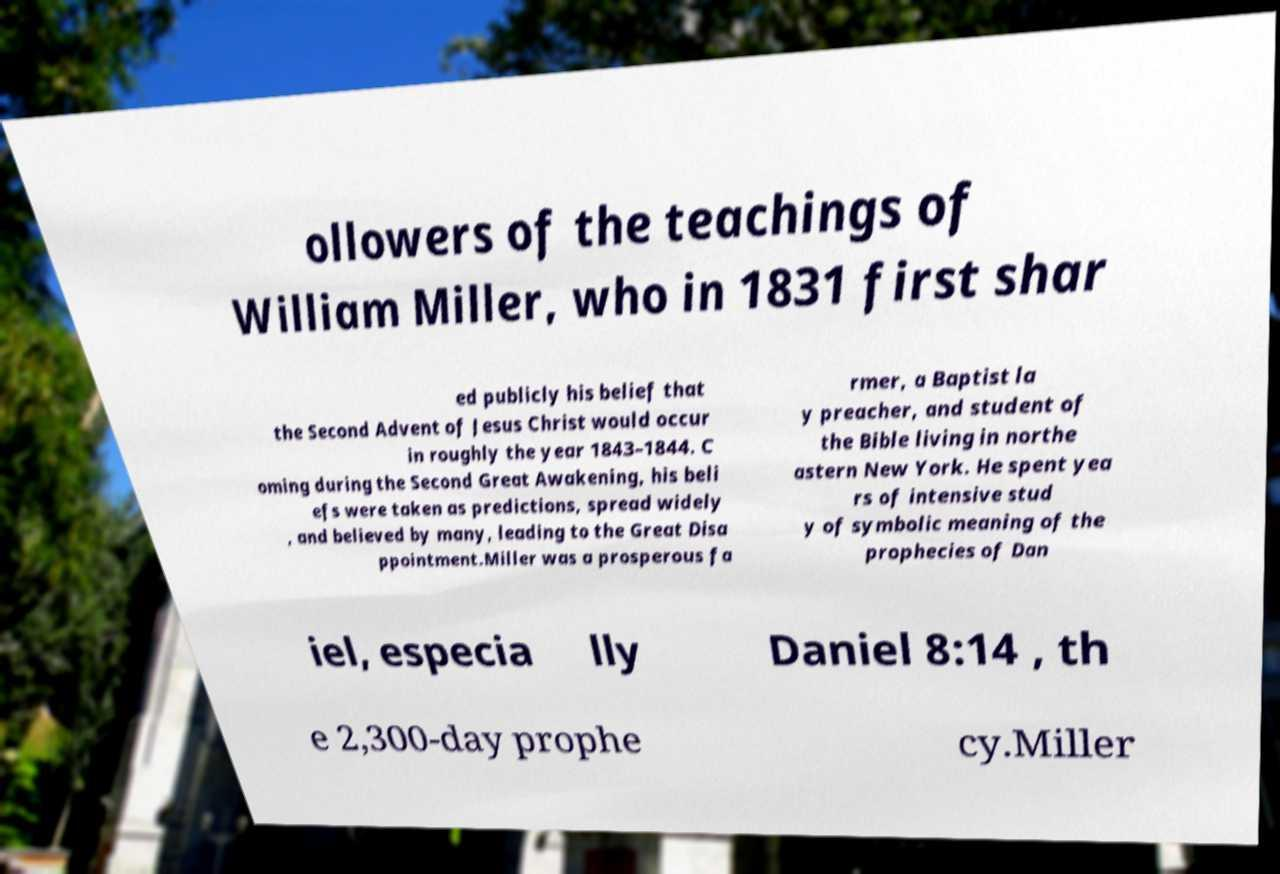Can you accurately transcribe the text from the provided image for me? ollowers of the teachings of William Miller, who in 1831 first shar ed publicly his belief that the Second Advent of Jesus Christ would occur in roughly the year 1843–1844. C oming during the Second Great Awakening, his beli efs were taken as predictions, spread widely , and believed by many, leading to the Great Disa ppointment.Miller was a prosperous fa rmer, a Baptist la y preacher, and student of the Bible living in northe astern New York. He spent yea rs of intensive stud y of symbolic meaning of the prophecies of Dan iel, especia lly Daniel 8:14 , th e 2,300-day prophe cy.Miller 